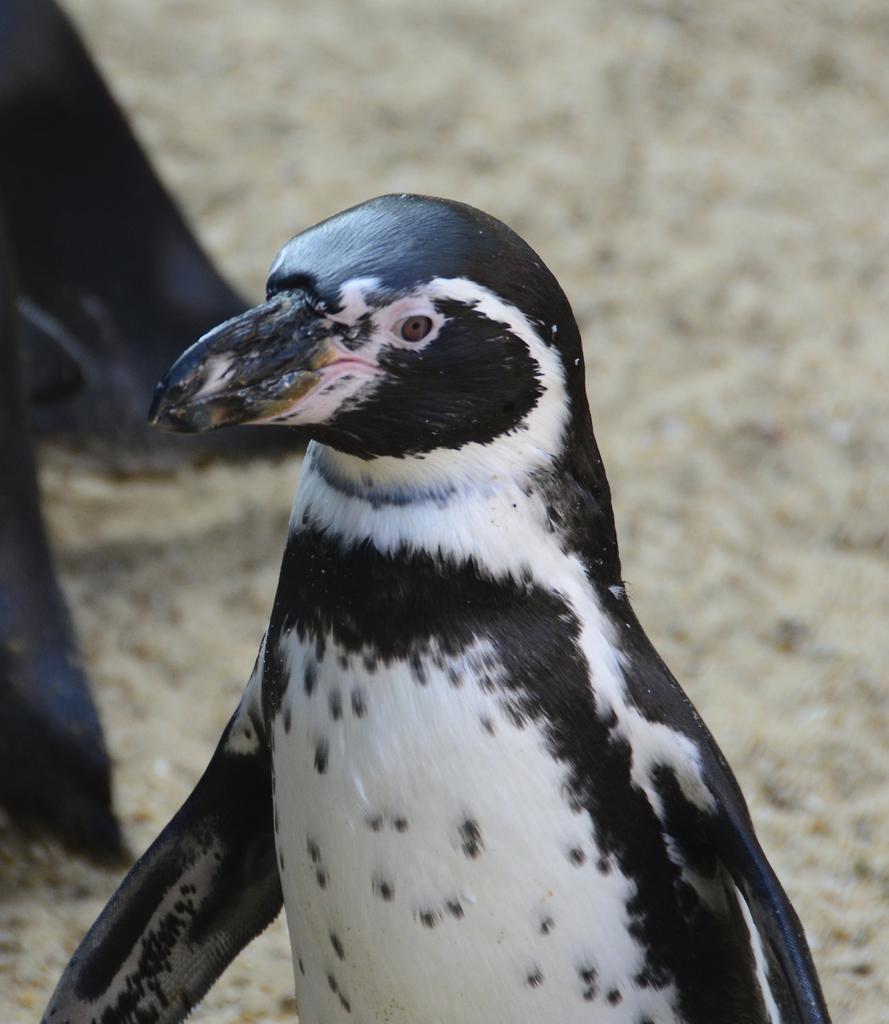Can you describe this image briefly? In this image there is a penguin in the middle. The colour of penguin is black and white. In the background there is ground. 